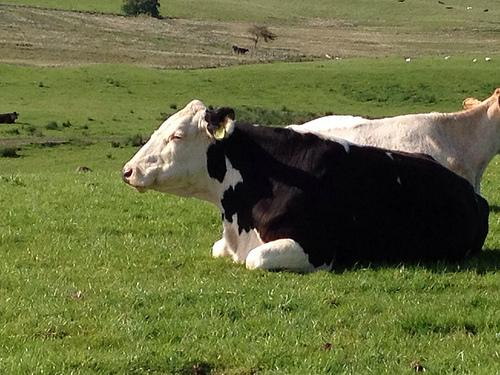Question: where was the picture taken?
Choices:
A. At a farm.
B. In the country.
C. Rural area.
D. In the fields.
Answer with the letter. Answer: D Question: what are the cows doing?
Choices:
A. Resting.
B. Grazing.
C. Eating.
D. Standing in the grass.
Answer with the letter. Answer: A Question: how is the weather?
Choices:
A. Cloudy.
B. Sunny.
C. Overcast.
D. Windy.
Answer with the letter. Answer: B 